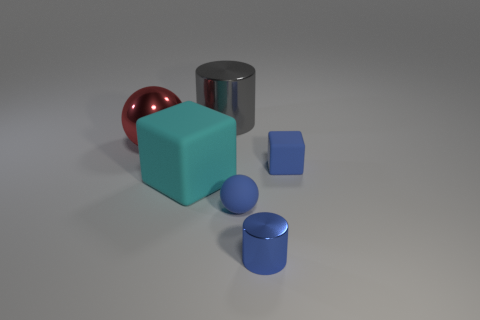Add 3 big matte things. How many objects exist? 9 Subtract all cylinders. How many objects are left? 4 Add 3 gray metallic cylinders. How many gray metallic cylinders are left? 4 Add 4 blue balls. How many blue balls exist? 5 Subtract 1 blue spheres. How many objects are left? 5 Subtract all metal spheres. Subtract all gray metal things. How many objects are left? 4 